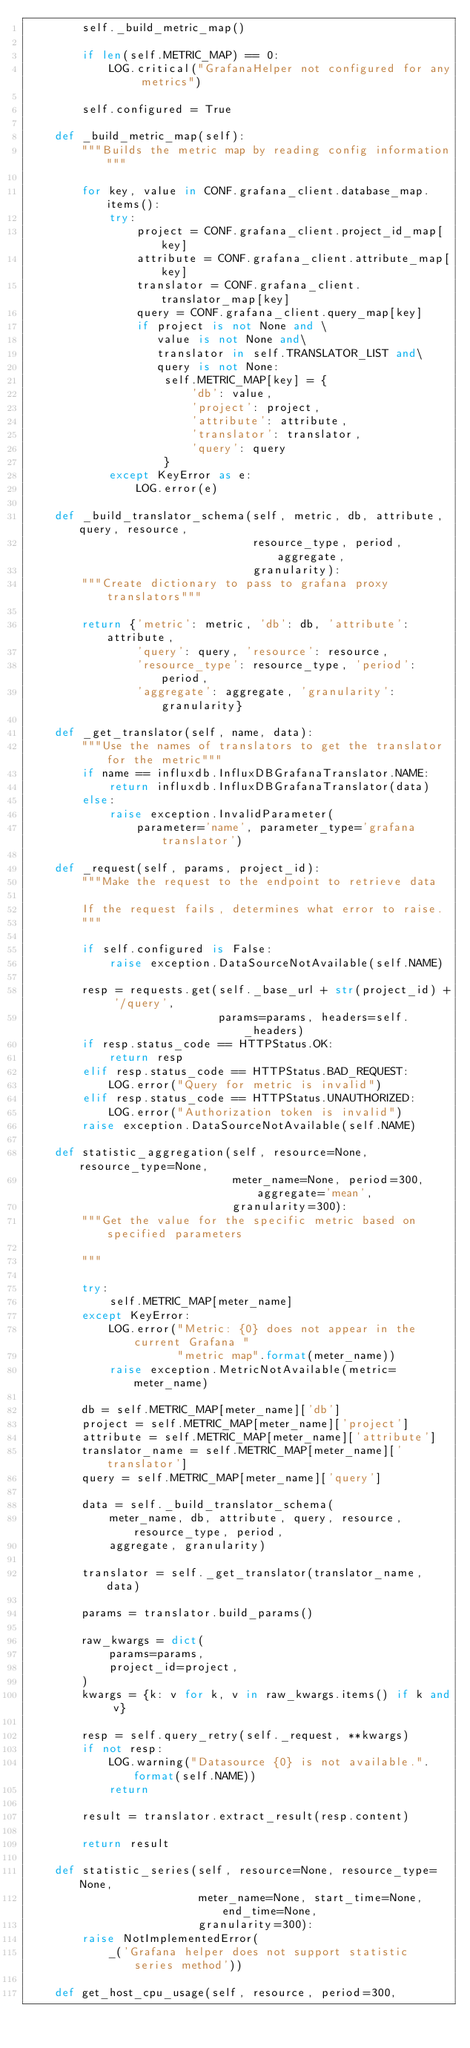Convert code to text. <code><loc_0><loc_0><loc_500><loc_500><_Python_>        self._build_metric_map()

        if len(self.METRIC_MAP) == 0:
            LOG.critical("GrafanaHelper not configured for any metrics")

        self.configured = True

    def _build_metric_map(self):
        """Builds the metric map by reading config information"""

        for key, value in CONF.grafana_client.database_map.items():
            try:
                project = CONF.grafana_client.project_id_map[key]
                attribute = CONF.grafana_client.attribute_map[key]
                translator = CONF.grafana_client.translator_map[key]
                query = CONF.grafana_client.query_map[key]
                if project is not None and \
                   value is not None and\
                   translator in self.TRANSLATOR_LIST and\
                   query is not None:
                    self.METRIC_MAP[key] = {
                        'db': value,
                        'project': project,
                        'attribute': attribute,
                        'translator': translator,
                        'query': query
                    }
            except KeyError as e:
                LOG.error(e)

    def _build_translator_schema(self, metric, db, attribute, query, resource,
                                 resource_type, period, aggregate,
                                 granularity):
        """Create dictionary to pass to grafana proxy translators"""

        return {'metric': metric, 'db': db, 'attribute': attribute,
                'query': query, 'resource': resource,
                'resource_type': resource_type, 'period': period,
                'aggregate': aggregate, 'granularity': granularity}

    def _get_translator(self, name, data):
        """Use the names of translators to get the translator for the metric"""
        if name == influxdb.InfluxDBGrafanaTranslator.NAME:
            return influxdb.InfluxDBGrafanaTranslator(data)
        else:
            raise exception.InvalidParameter(
                parameter='name', parameter_type='grafana translator')

    def _request(self, params, project_id):
        """Make the request to the endpoint to retrieve data

        If the request fails, determines what error to raise.
        """

        if self.configured is False:
            raise exception.DataSourceNotAvailable(self.NAME)

        resp = requests.get(self._base_url + str(project_id) + '/query',
                            params=params, headers=self._headers)
        if resp.status_code == HTTPStatus.OK:
            return resp
        elif resp.status_code == HTTPStatus.BAD_REQUEST:
            LOG.error("Query for metric is invalid")
        elif resp.status_code == HTTPStatus.UNAUTHORIZED:
            LOG.error("Authorization token is invalid")
        raise exception.DataSourceNotAvailable(self.NAME)

    def statistic_aggregation(self, resource=None, resource_type=None,
                              meter_name=None, period=300, aggregate='mean',
                              granularity=300):
        """Get the value for the specific metric based on specified parameters

        """

        try:
            self.METRIC_MAP[meter_name]
        except KeyError:
            LOG.error("Metric: {0} does not appear in the current Grafana "
                      "metric map".format(meter_name))
            raise exception.MetricNotAvailable(metric=meter_name)

        db = self.METRIC_MAP[meter_name]['db']
        project = self.METRIC_MAP[meter_name]['project']
        attribute = self.METRIC_MAP[meter_name]['attribute']
        translator_name = self.METRIC_MAP[meter_name]['translator']
        query = self.METRIC_MAP[meter_name]['query']

        data = self._build_translator_schema(
            meter_name, db, attribute, query, resource, resource_type, period,
            aggregate, granularity)

        translator = self._get_translator(translator_name, data)

        params = translator.build_params()

        raw_kwargs = dict(
            params=params,
            project_id=project,
        )
        kwargs = {k: v for k, v in raw_kwargs.items() if k and v}

        resp = self.query_retry(self._request, **kwargs)
        if not resp:
            LOG.warning("Datasource {0} is not available.".format(self.NAME))
            return

        result = translator.extract_result(resp.content)

        return result

    def statistic_series(self, resource=None, resource_type=None,
                         meter_name=None, start_time=None, end_time=None,
                         granularity=300):
        raise NotImplementedError(
            _('Grafana helper does not support statistic series method'))

    def get_host_cpu_usage(self, resource, period=300,</code> 